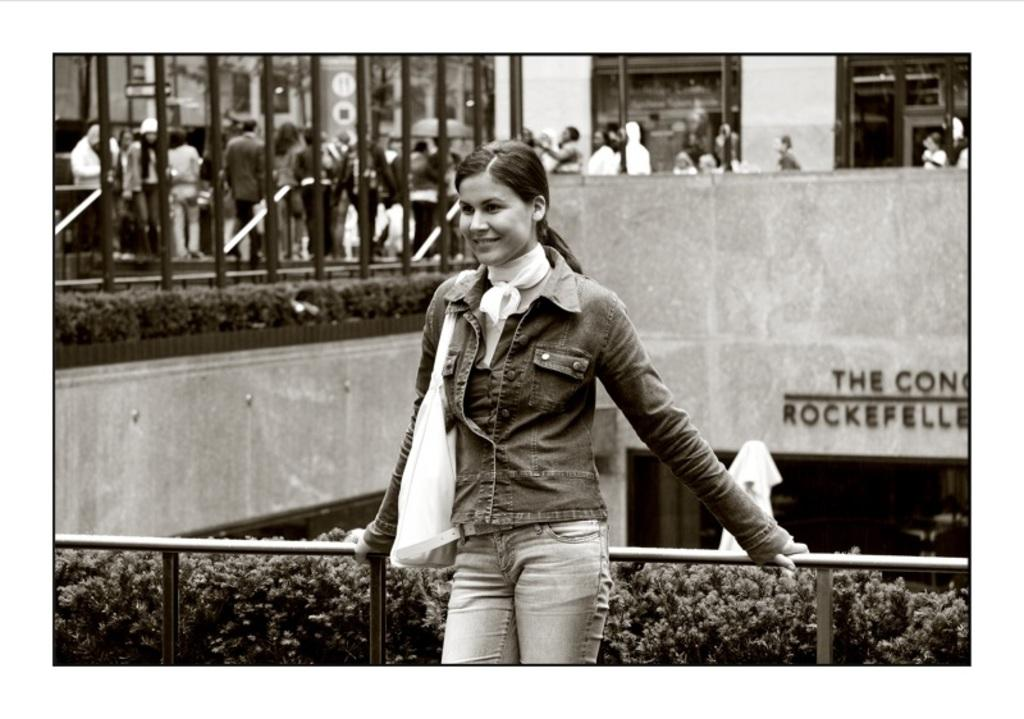Who is the main subject in the image? There is a woman in the image. What is the woman holding in the image? The woman is holding a rod. What is the woman doing in the image? The woman is posing for a photograph. What can be seen in the background of the image? There is a building and a bridge in the background of the image. What is happening on the bridge in the image? People are walking on the bridge. What type of cloth is draped over the frame in the image? There is no frame or cloth present in the image. What might surprise the woman in the image? The image does not provide any information about what might surprise the woman, as it only shows her posing for a photograph. 